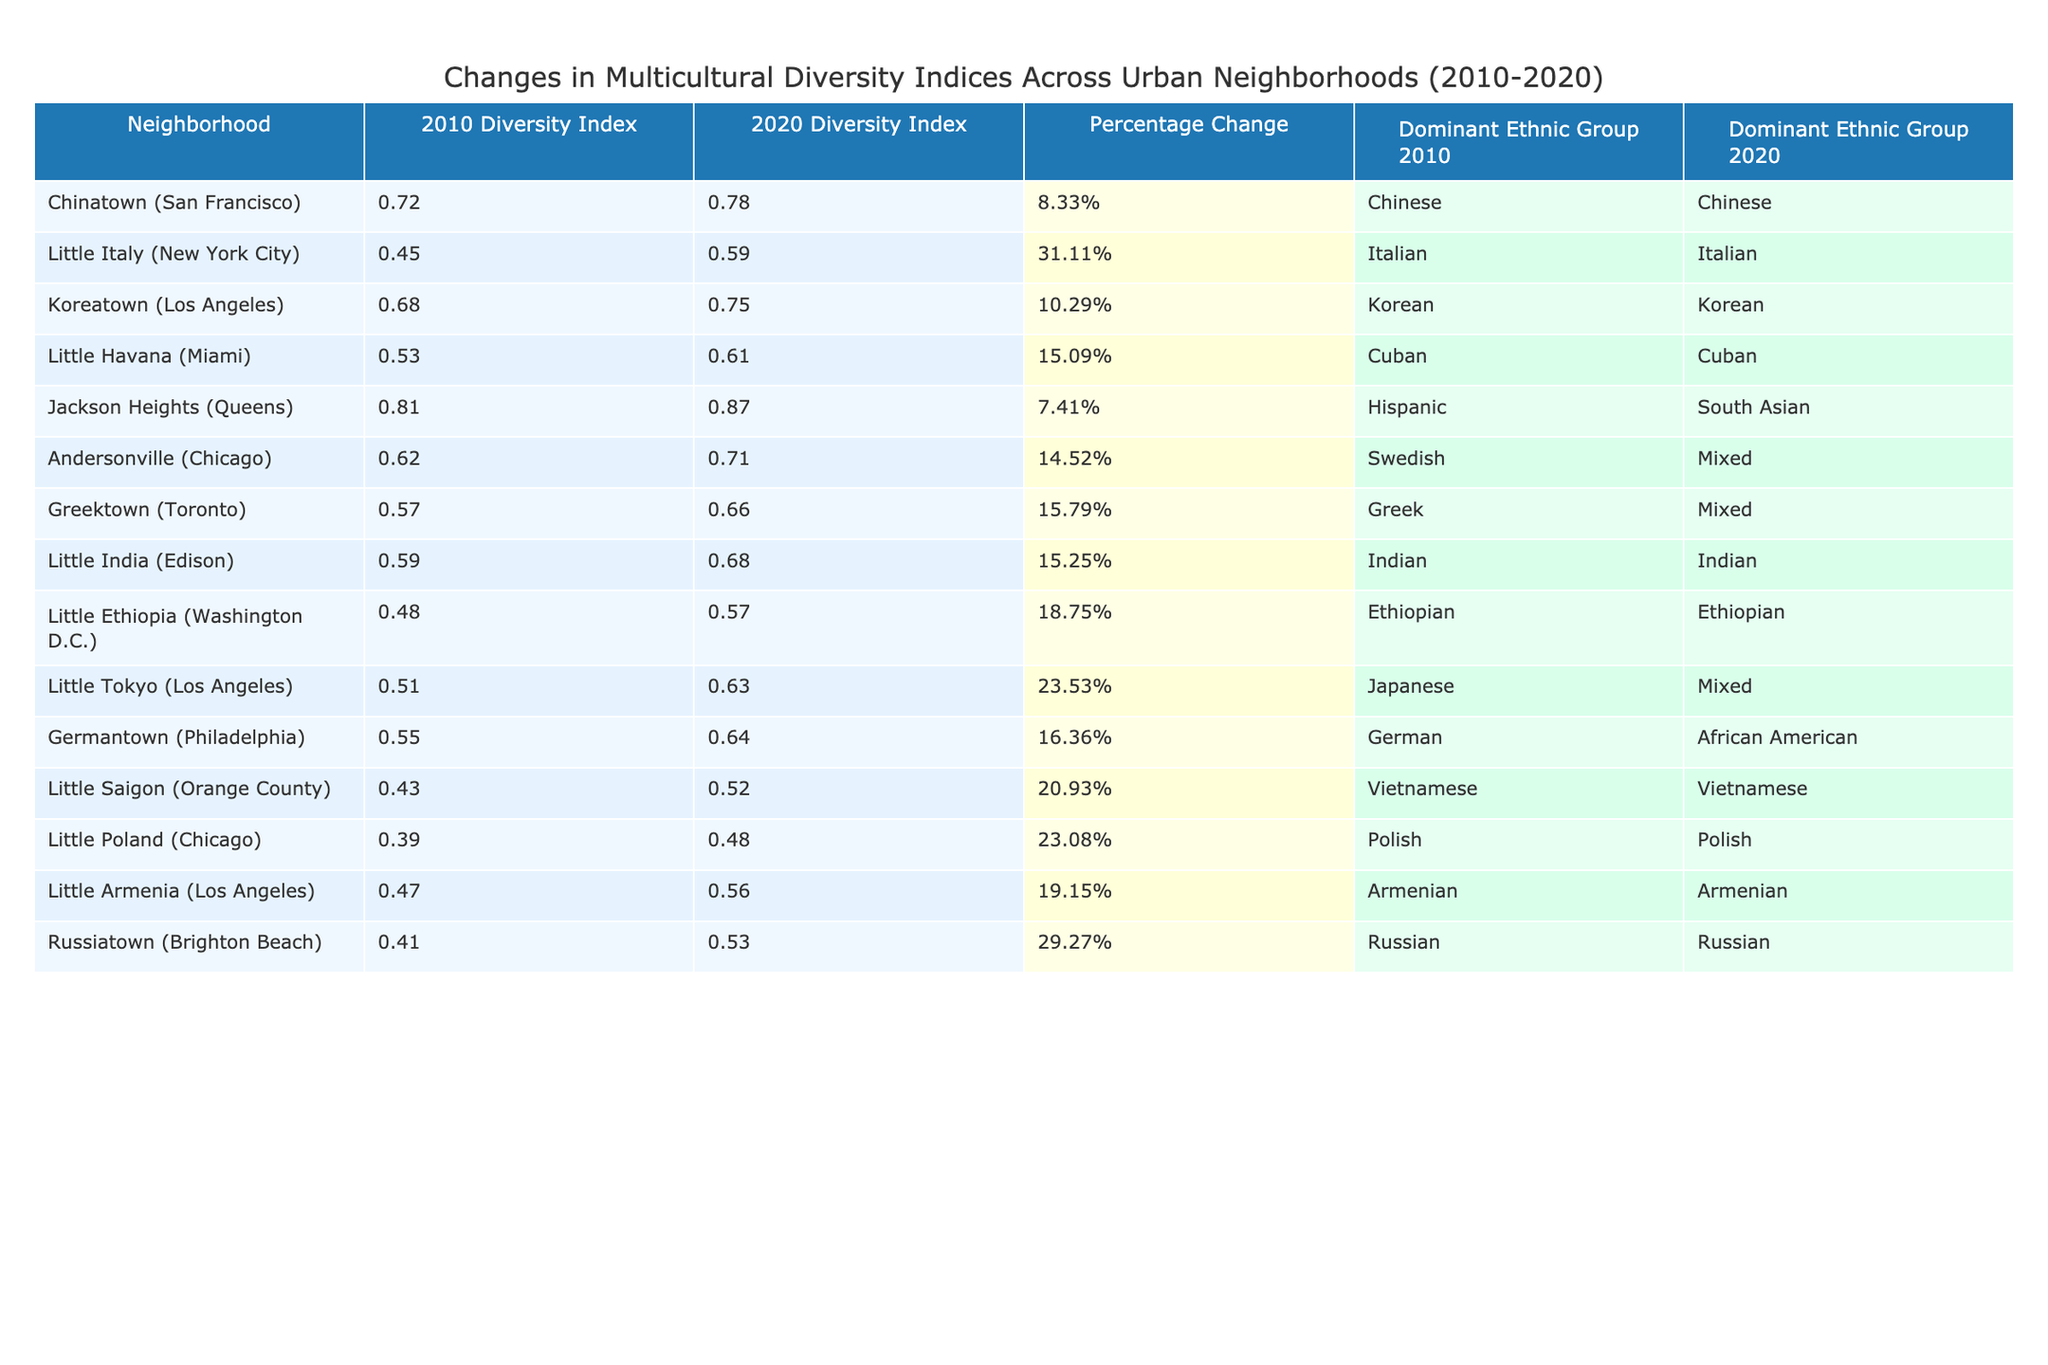What was the diversity index of Jackson Heights in 2010? According to the table, Jackson Heights had a diversity index of 0.81 in 2010.
Answer: 0.81 Which neighborhood experienced the highest percentage change in its diversity index? By comparing the percentage changes, Little Italy experienced the highest increase at 31.11%.
Answer: Little Italy Is the dominant ethnic group in Chinatown the same in 2020 as it was in 2010? The table indicates that the dominant ethnic group in Chinatown remained Chinese in both 2010 and 2020.
Answer: Yes What is the average diversity index for the neighborhoods listed in 2020? By adding all diversity indices for 2020 (0.78 + 0.59 + 0.75 + 0.61 + 0.87 + 0.71 + 0.66 + 0.68 + 0.57 + 0.63 + 0.64 + 0.52 + 0.48 + 0.56 + 0.53) = 9.08 and dividing by the number of neighborhoods (15), the average is 9.08 / 15 = 0.6053.
Answer: 0.6053 Did any neighborhood's dominant ethnic group change from 2010 to 2020? If so, which neighborhoods changed? The only neighborhood that changed its dominant ethnic group was Jackson Heights, which shifted from Hispanic to South Asian.
Answer: Yes, Jackson Heights What is the percentage change in diversity index for Little Ethiopia? The diversity index for Little Ethiopia changed from 0.48 in 2010 to 0.57 in 2020, resulting in a percentage change of 18.75%.
Answer: 18.75% Which neighborhood had a 10% or more increase in diversity index but maintained the same dominant ethnic group? Both Koreatown and Little India had increases greater than 10% (10.29% and 15.25% respectively) while retaining their dominant ethnic groups (Korean and Indian).
Answer: Koreatown, Little India What is the total number of neighborhoods listed? The table lists 15 neighborhoods in total.
Answer: 15 Between which two years was the diversity index for Greektown recorded? The diversity index for Greektown was recorded for the years 2010 and 2020.
Answer: 2010 and 2020 What was the diversity index for Little Poland in 2020? According to the table, Little Poland had a diversity index of 0.48 in 2020.
Answer: 0.48 Which neighborhood had the lowest diversity index in 2010, and what was that index? Little Poland had the lowest diversity index in 2010 at 0.39.
Answer: Little Poland, 0.39 